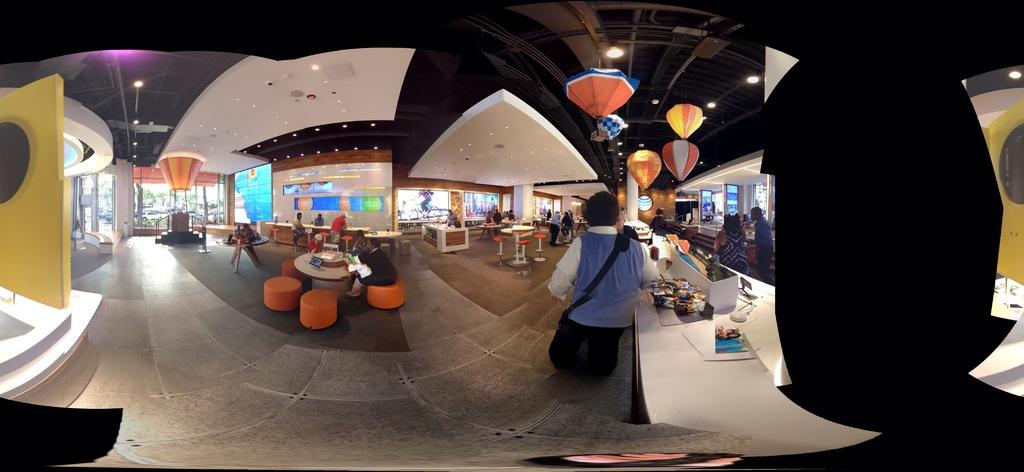What is happening inside the building in the image? There are people in the building. What type of furniture is visible in the image? There are tables and chairs in the image. What is on top of the tables? There are objects on the tables. What can be seen providing illumination in the image? There are lights in the image. What decorations are hanging from the ceiling? There are balloons attached to the ceiling. What caused the mother to visit the building during the week? There is no information about a mother or a specific week in the image, so we cannot determine the cause of her visit. 